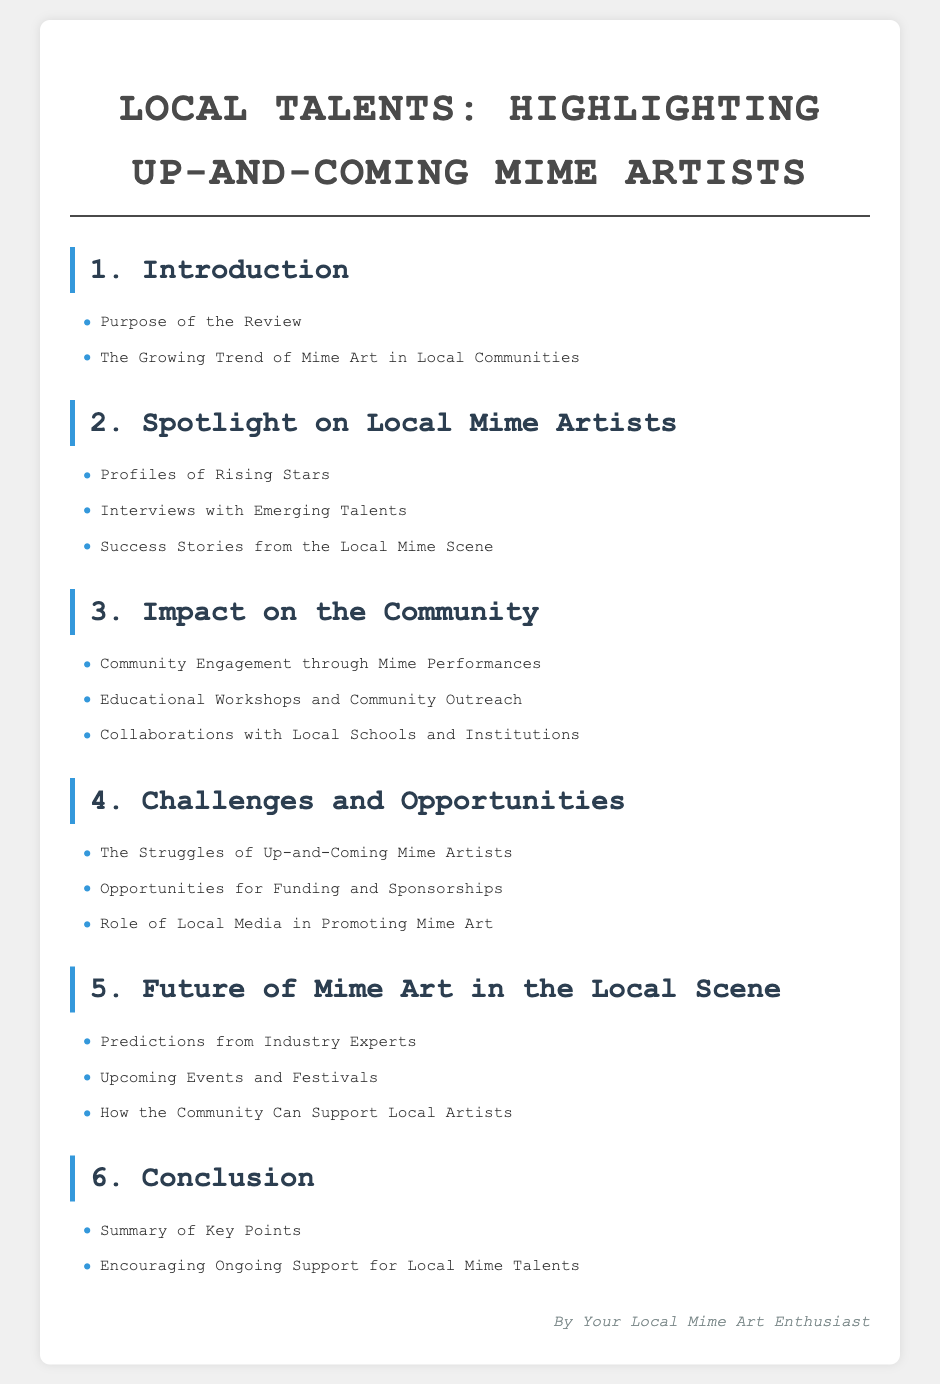What is the purpose of the review? The purpose of the review is stated in the introduction section of the document.
Answer: Purpose of the Review How many sections are in the document? The document has a total of six main sections outlined in the table of contents.
Answer: 6 Who is the author of the document? The author is indicated at the end of the document.
Answer: Your Local Mime Art Enthusiast What are community workshops aimed at? The document mentions this topic in the section about community impact.
Answer: Educational Workshops and Community Outreach What challenges do up-and-coming mime artists face? This information is found in the Challenges and Opportunities section.
Answer: The Struggles of Up-and-Coming Mime Artists What can the community do to support local artists? This is discussed in the Future of Mime Art section of the document.
Answer: How the Community Can Support Local Artists What is highlighted in the second section? The second section focuses on individuals within the mime community.
Answer: Profiles of Rising Stars What is addressed in the conclusion? The conclusion summarizes the overall findings of the document.
Answer: Summary of Key Points 